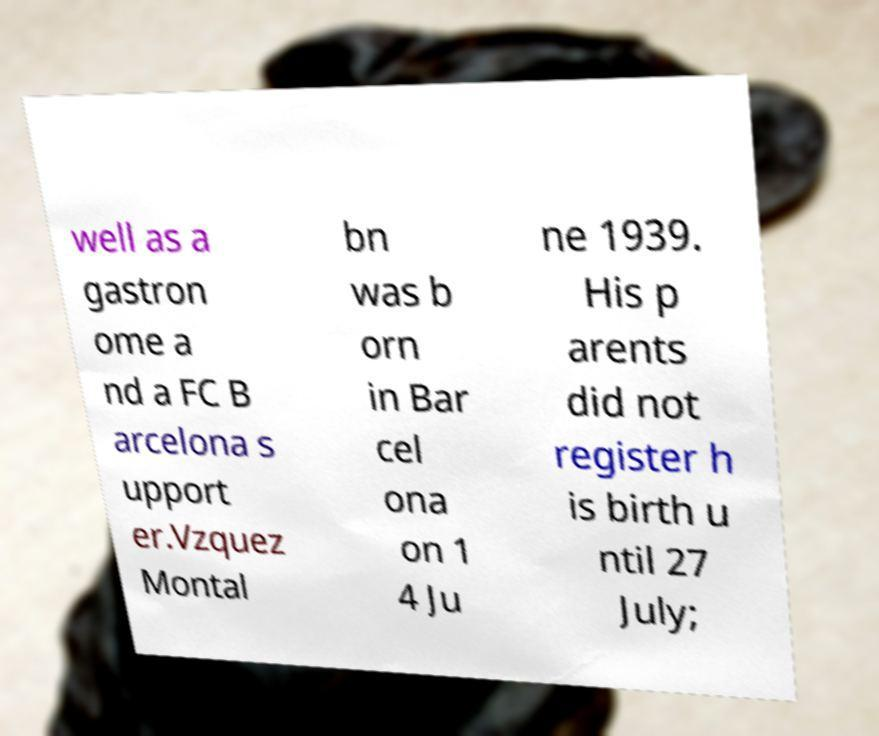Could you extract and type out the text from this image? well as a gastron ome a nd a FC B arcelona s upport er.Vzquez Montal bn was b orn in Bar cel ona on 1 4 Ju ne 1939. His p arents did not register h is birth u ntil 27 July; 